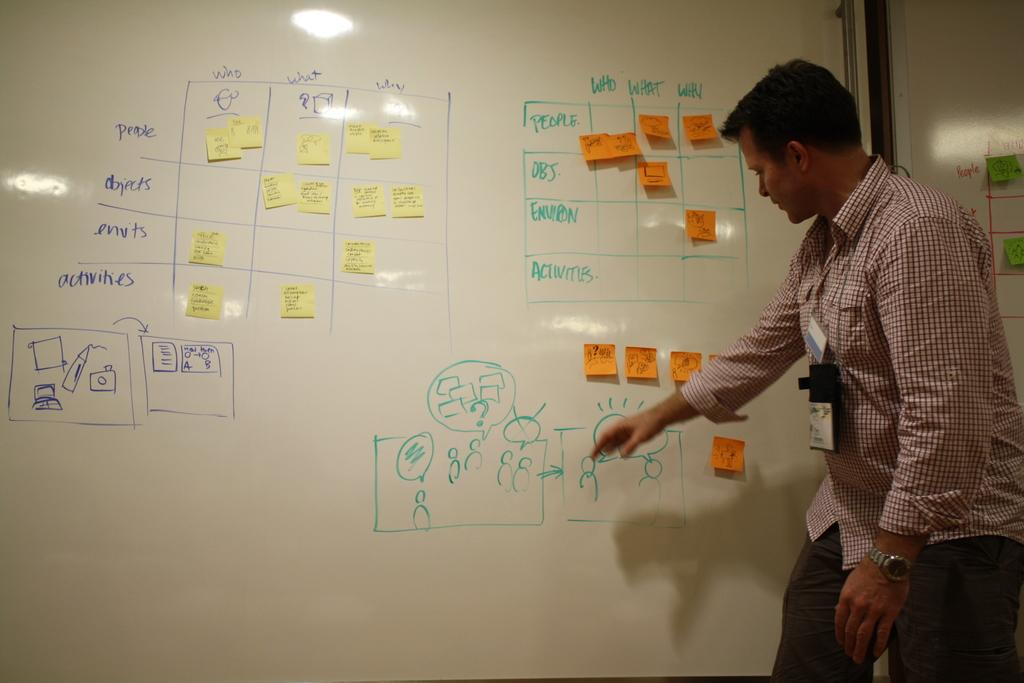<image>
Summarize the visual content of the image. Two charts both have columns with the headings of who, what and why. 